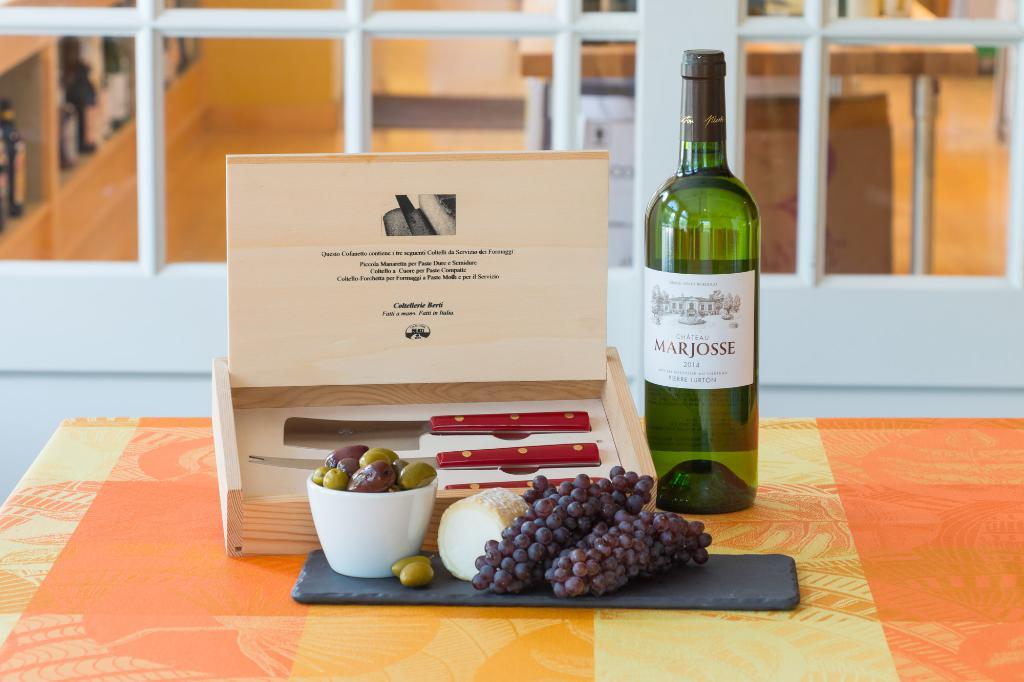What is the last letter in the name of the wine?
Provide a succinct answer. E. 